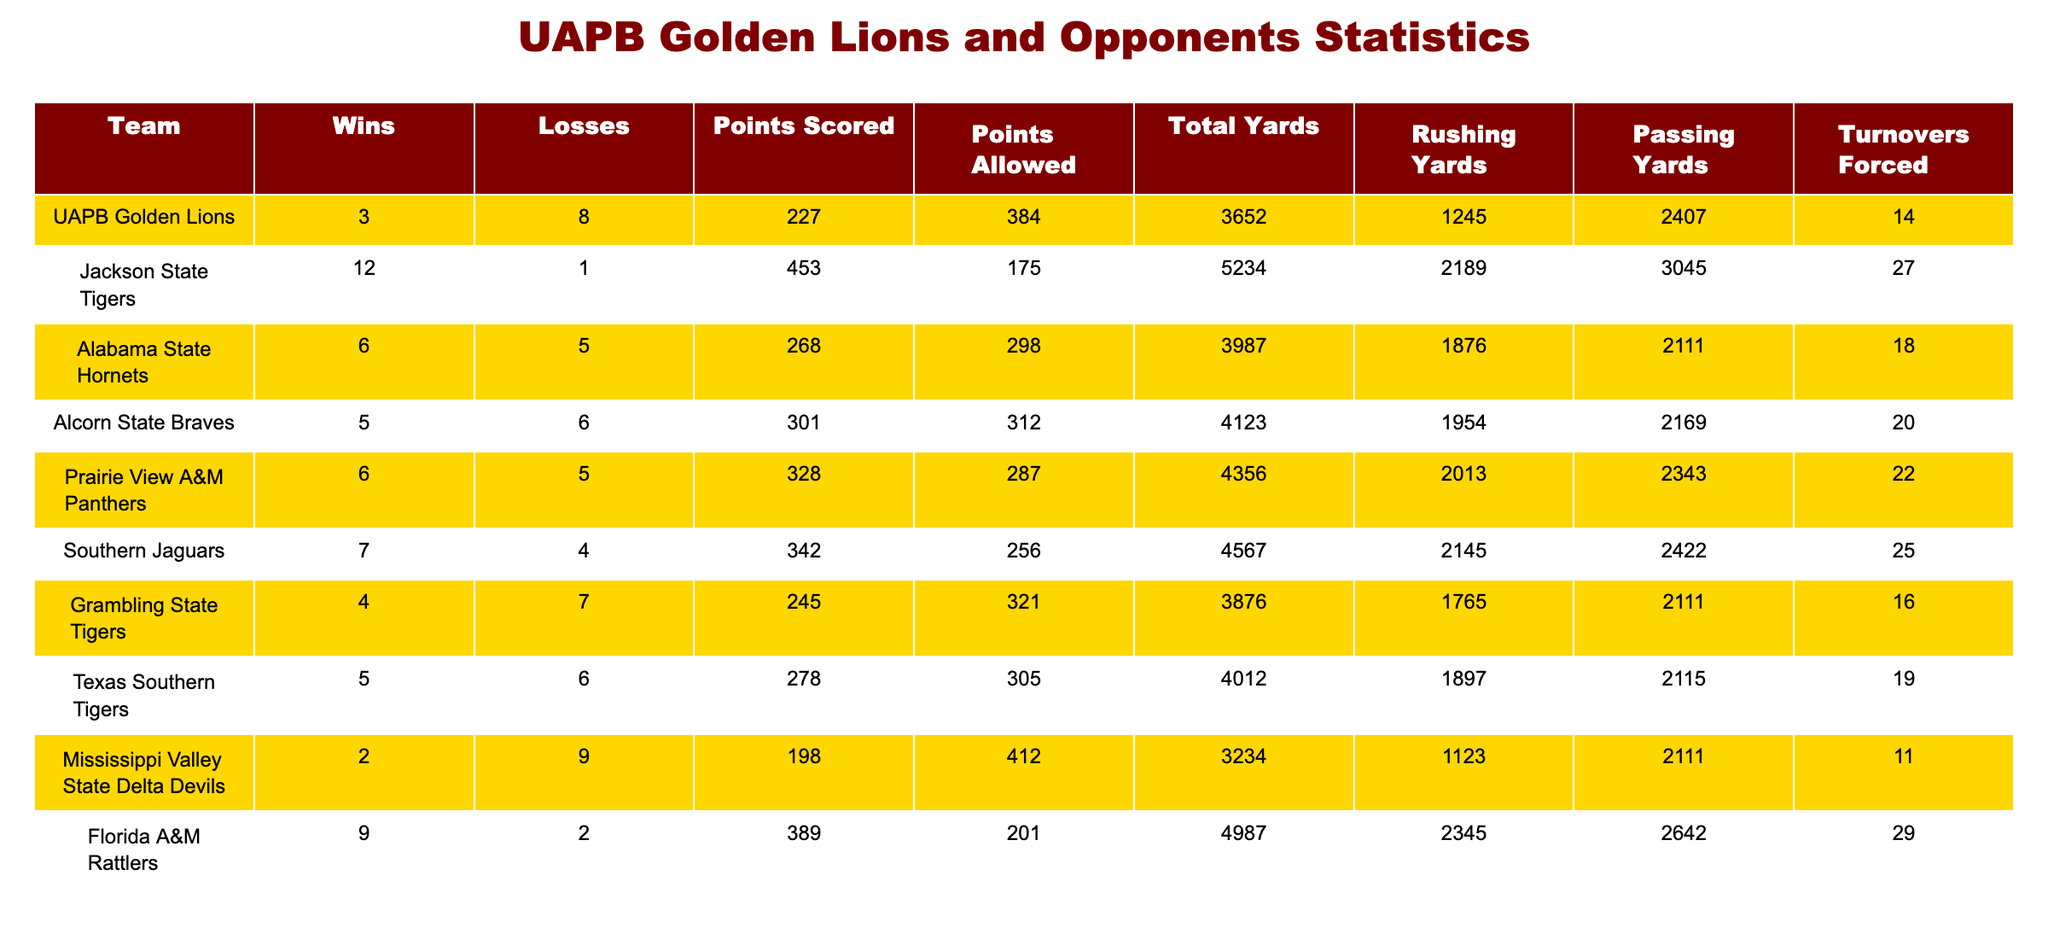What was the total number of points scored by the UAPB Golden Lions? The table shows that the UAPB Golden Lions scored 227 points during the season.
Answer: 227 How many turnovers did the Southern Jaguars force? From the table, it is stated that the Southern Jaguars forced 25 turnovers.
Answer: 25 Which team had the least number of wins? The Mississippi Valley State Delta Devils had only 2 wins, which is fewer than any other team listed in the table.
Answer: Mississippi Valley State Delta Devils What is the difference between the total yards of UAPB Golden Lions and the Alabama State Hornets? UAPB Golden Lions had total yards of 3652 and Alabama State Hornets had 3987 total yards. The difference is 3987 - 3652 = 335 yards.
Answer: 335 Did UAPB allow more points than they scored this season? UAPB scored 227 points and allowed 384 points, which means they allowed more points than they scored (384 > 227).
Answer: Yes What was the average number of rushing yards for the top three teams in terms of points scored? The top three teams in points scored are Jackson State (2189), Florida A&M (2345), and Southern Jaguars (2145). Their rushing yards are 2189, 2345, and 2145, respectively. The sum is 2189 + 2345 + 2145 = 6679, and the average is 6679 / 3 = 2226.33.
Answer: 2226.33 Which team had the highest points allowed and what was that number? The Mississippi Valley State Delta Devils allowed the most points at 412, which is greater than any other team in the table.
Answer: 412 How many teams had a winning record (more wins than losses)? To find the teams with winning records, we look for teams with more wins than losses. The teams with winning records are Jackson State (12-1), Florida A&M (9-2), Southern Jaguars (7-4), and Alabama State (6-5). That totals 4 teams.
Answer: 4 What percentage of total yards did the UAPB Golden Lions achieve in rushing yards? The UAPB Golden Lions had 1245 rushing yards out of a total of 3652 yards. To find the percentage, we calculate (1245 / 3652) * 100 = 34.14%.
Answer: 34.14% 